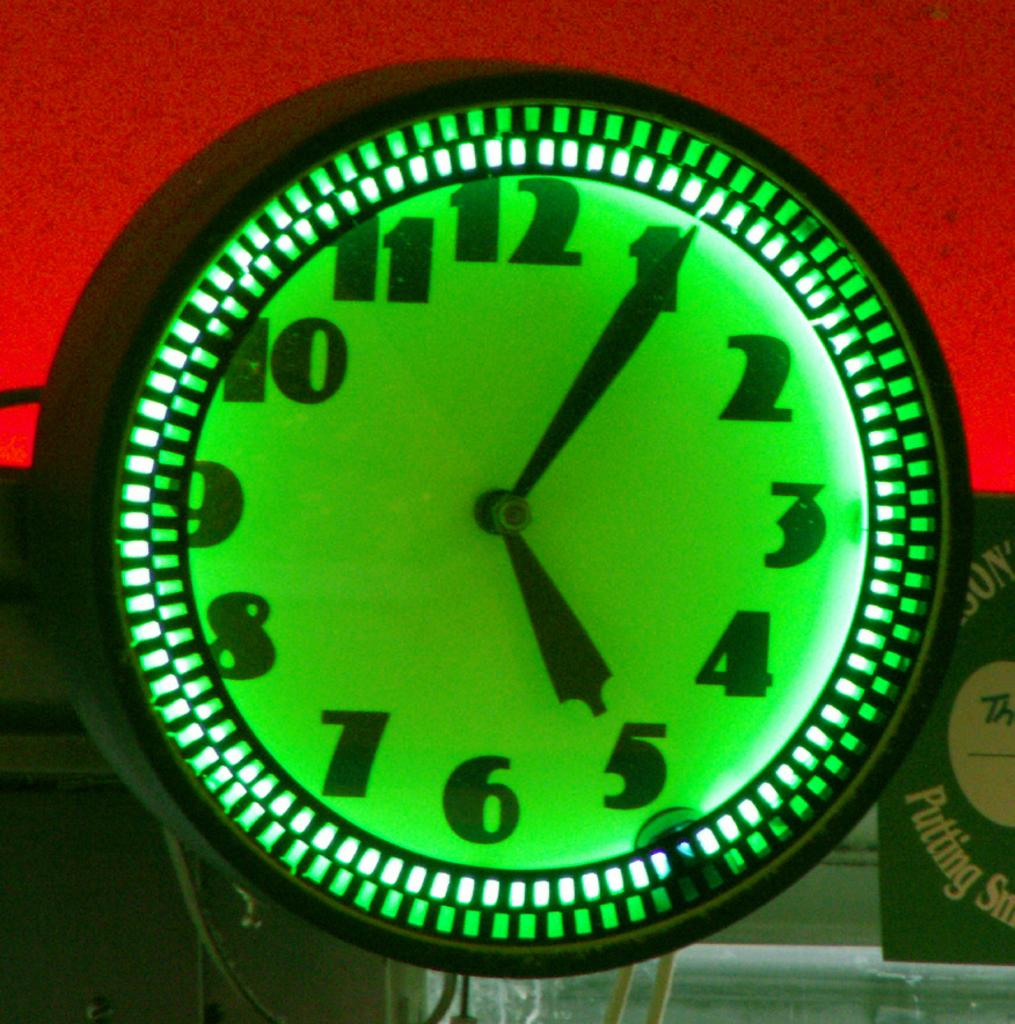<image>
Offer a succinct explanation of the picture presented. A green neon lit clock whose time reads 5:05 on its face. 